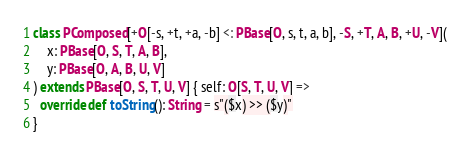Convert code to text. <code><loc_0><loc_0><loc_500><loc_500><_Scala_>class PComposed[+O[-s, +t, +a, -b] <: PBase[O, s, t, a, b], -S, +T, A, B, +U, -V](
    x: PBase[O, S, T, A, B],
    y: PBase[O, A, B, U, V]
) extends PBase[O, S, T, U, V] { self: O[S, T, U, V] =>
  override def toString(): String = s"($x) >> ($y)"
}
</code> 